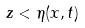Convert formula to latex. <formula><loc_0><loc_0><loc_500><loc_500>z < \eta ( x , t )</formula> 